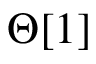Convert formula to latex. <formula><loc_0><loc_0><loc_500><loc_500>\Theta [ 1 ]</formula> 